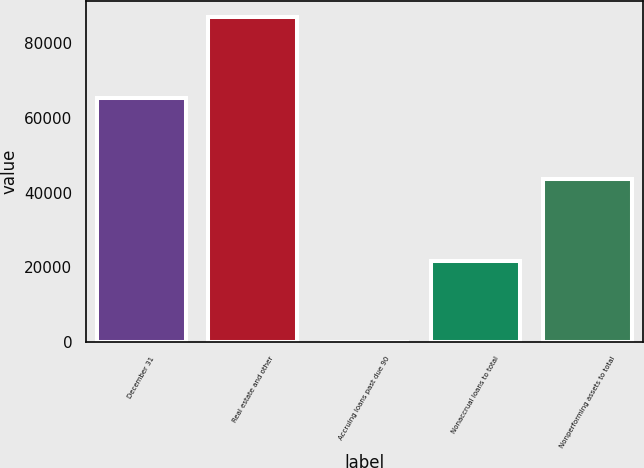<chart> <loc_0><loc_0><loc_500><loc_500><bar_chart><fcel>December 31<fcel>Real estate and other<fcel>Accruing loans past due 90<fcel>Nonaccrual loans to total<fcel>Nonperforming assets to total<nl><fcel>65346.8<fcel>87129<fcel>0.37<fcel>21782.5<fcel>43564.7<nl></chart> 